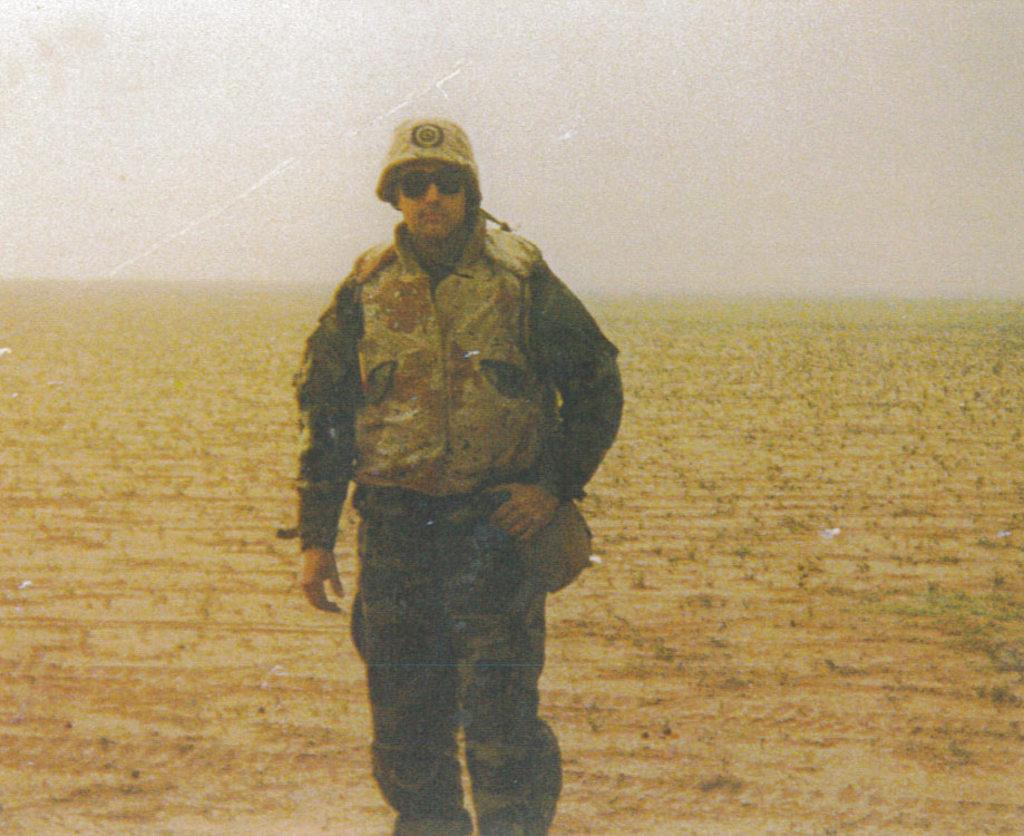What is the main subject of the image? There is a person standing in the image. What is the person wearing on their head? The person is wearing a cap. What is the person wearing to protect their eyes? The person is wearing goggles. What type of clothing is the person wearing? The person is wearing a uniform. What type of terrain is visible in the image? There is land visible in the image. What is visible at the top of the image? The sky is visible at the top of the image. How many jelly cubes can be seen on the person's uniform in the image? There are no jelly cubes present on the person's uniform in the image. How many men are visible in the image? The image only shows one person, not multiple men. 